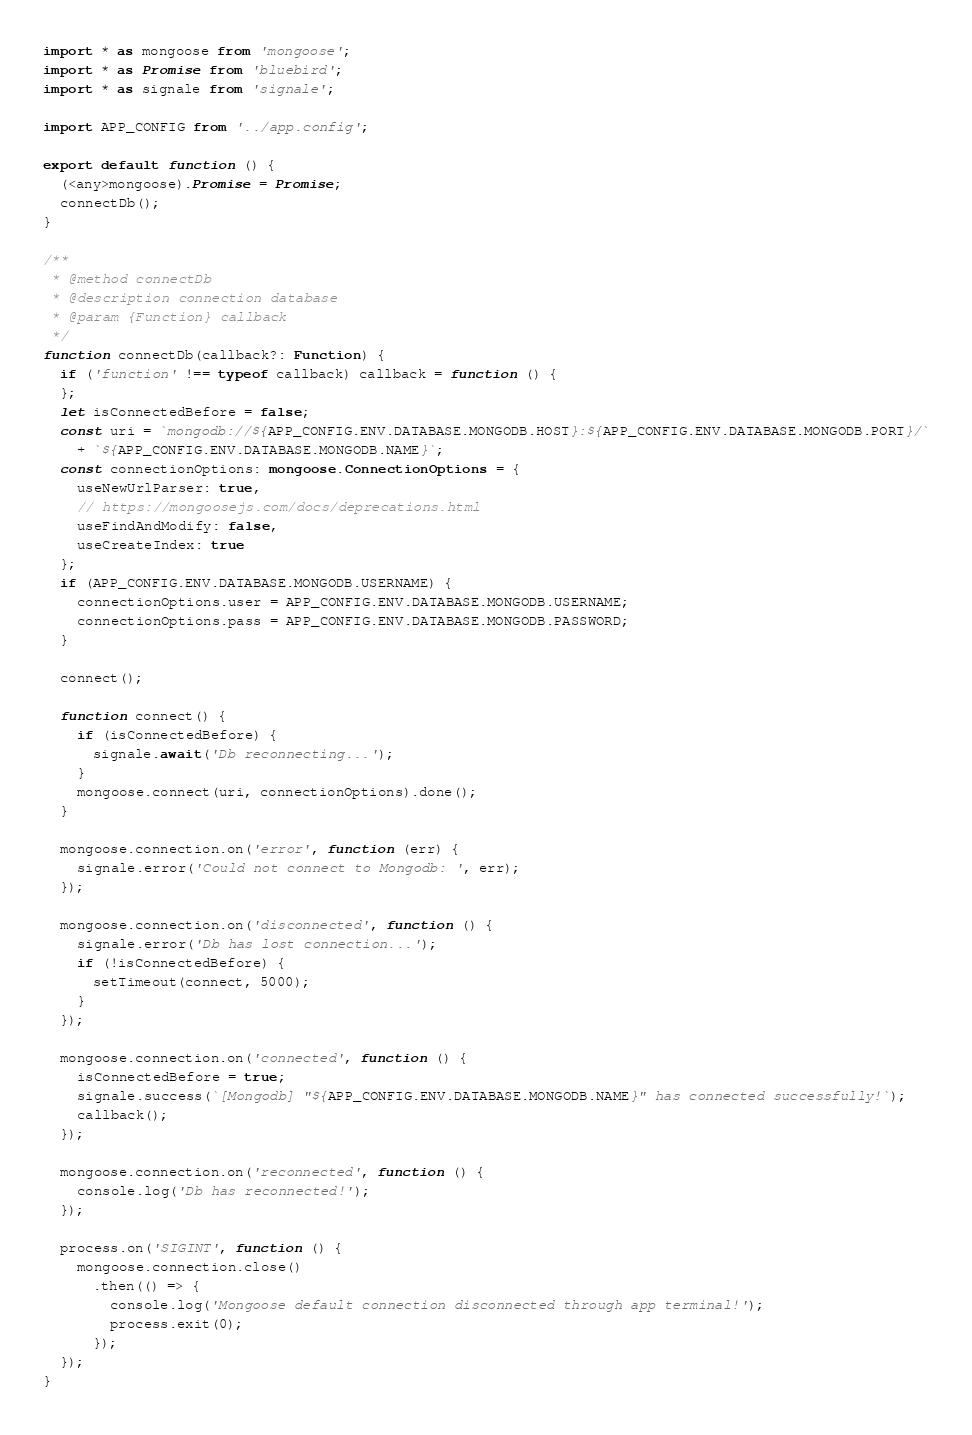Convert code to text. <code><loc_0><loc_0><loc_500><loc_500><_TypeScript_>import * as mongoose from 'mongoose';
import * as Promise from 'bluebird';
import * as signale from 'signale';

import APP_CONFIG from '../app.config';

export default function () {
  (<any>mongoose).Promise = Promise;
  connectDb();
}

/**
 * @method connectDb
 * @description connection database
 * @param {Function} callback
 */
function connectDb(callback?: Function) {
  if ('function' !== typeof callback) callback = function () {
  };
  let isConnectedBefore = false;
  const uri = `mongodb://${APP_CONFIG.ENV.DATABASE.MONGODB.HOST}:${APP_CONFIG.ENV.DATABASE.MONGODB.PORT}/`
    + `${APP_CONFIG.ENV.DATABASE.MONGODB.NAME}`;
  const connectionOptions: mongoose.ConnectionOptions = {
    useNewUrlParser: true,
    // https://mongoosejs.com/docs/deprecations.html
    useFindAndModify: false,
    useCreateIndex: true
  };
  if (APP_CONFIG.ENV.DATABASE.MONGODB.USERNAME) {
    connectionOptions.user = APP_CONFIG.ENV.DATABASE.MONGODB.USERNAME;
    connectionOptions.pass = APP_CONFIG.ENV.DATABASE.MONGODB.PASSWORD;
  }

  connect();

  function connect() {
    if (isConnectedBefore) {
      signale.await('Db reconnecting...');
    }
    mongoose.connect(uri, connectionOptions).done();
  }

  mongoose.connection.on('error', function (err) {
    signale.error('Could not connect to Mongodb: ', err);
  });

  mongoose.connection.on('disconnected', function () {
    signale.error('Db has lost connection...');
    if (!isConnectedBefore) {
      setTimeout(connect, 5000);
    }
  });

  mongoose.connection.on('connected', function () {
    isConnectedBefore = true;
    signale.success(`[Mongodb] "${APP_CONFIG.ENV.DATABASE.MONGODB.NAME}" has connected successfully!`);
    callback();
  });

  mongoose.connection.on('reconnected', function () {
    console.log('Db has reconnected!');
  });

  process.on('SIGINT', function () {
    mongoose.connection.close()
      .then(() => {
        console.log('Mongoose default connection disconnected through app terminal!');
        process.exit(0);
      });
  });
}
</code> 